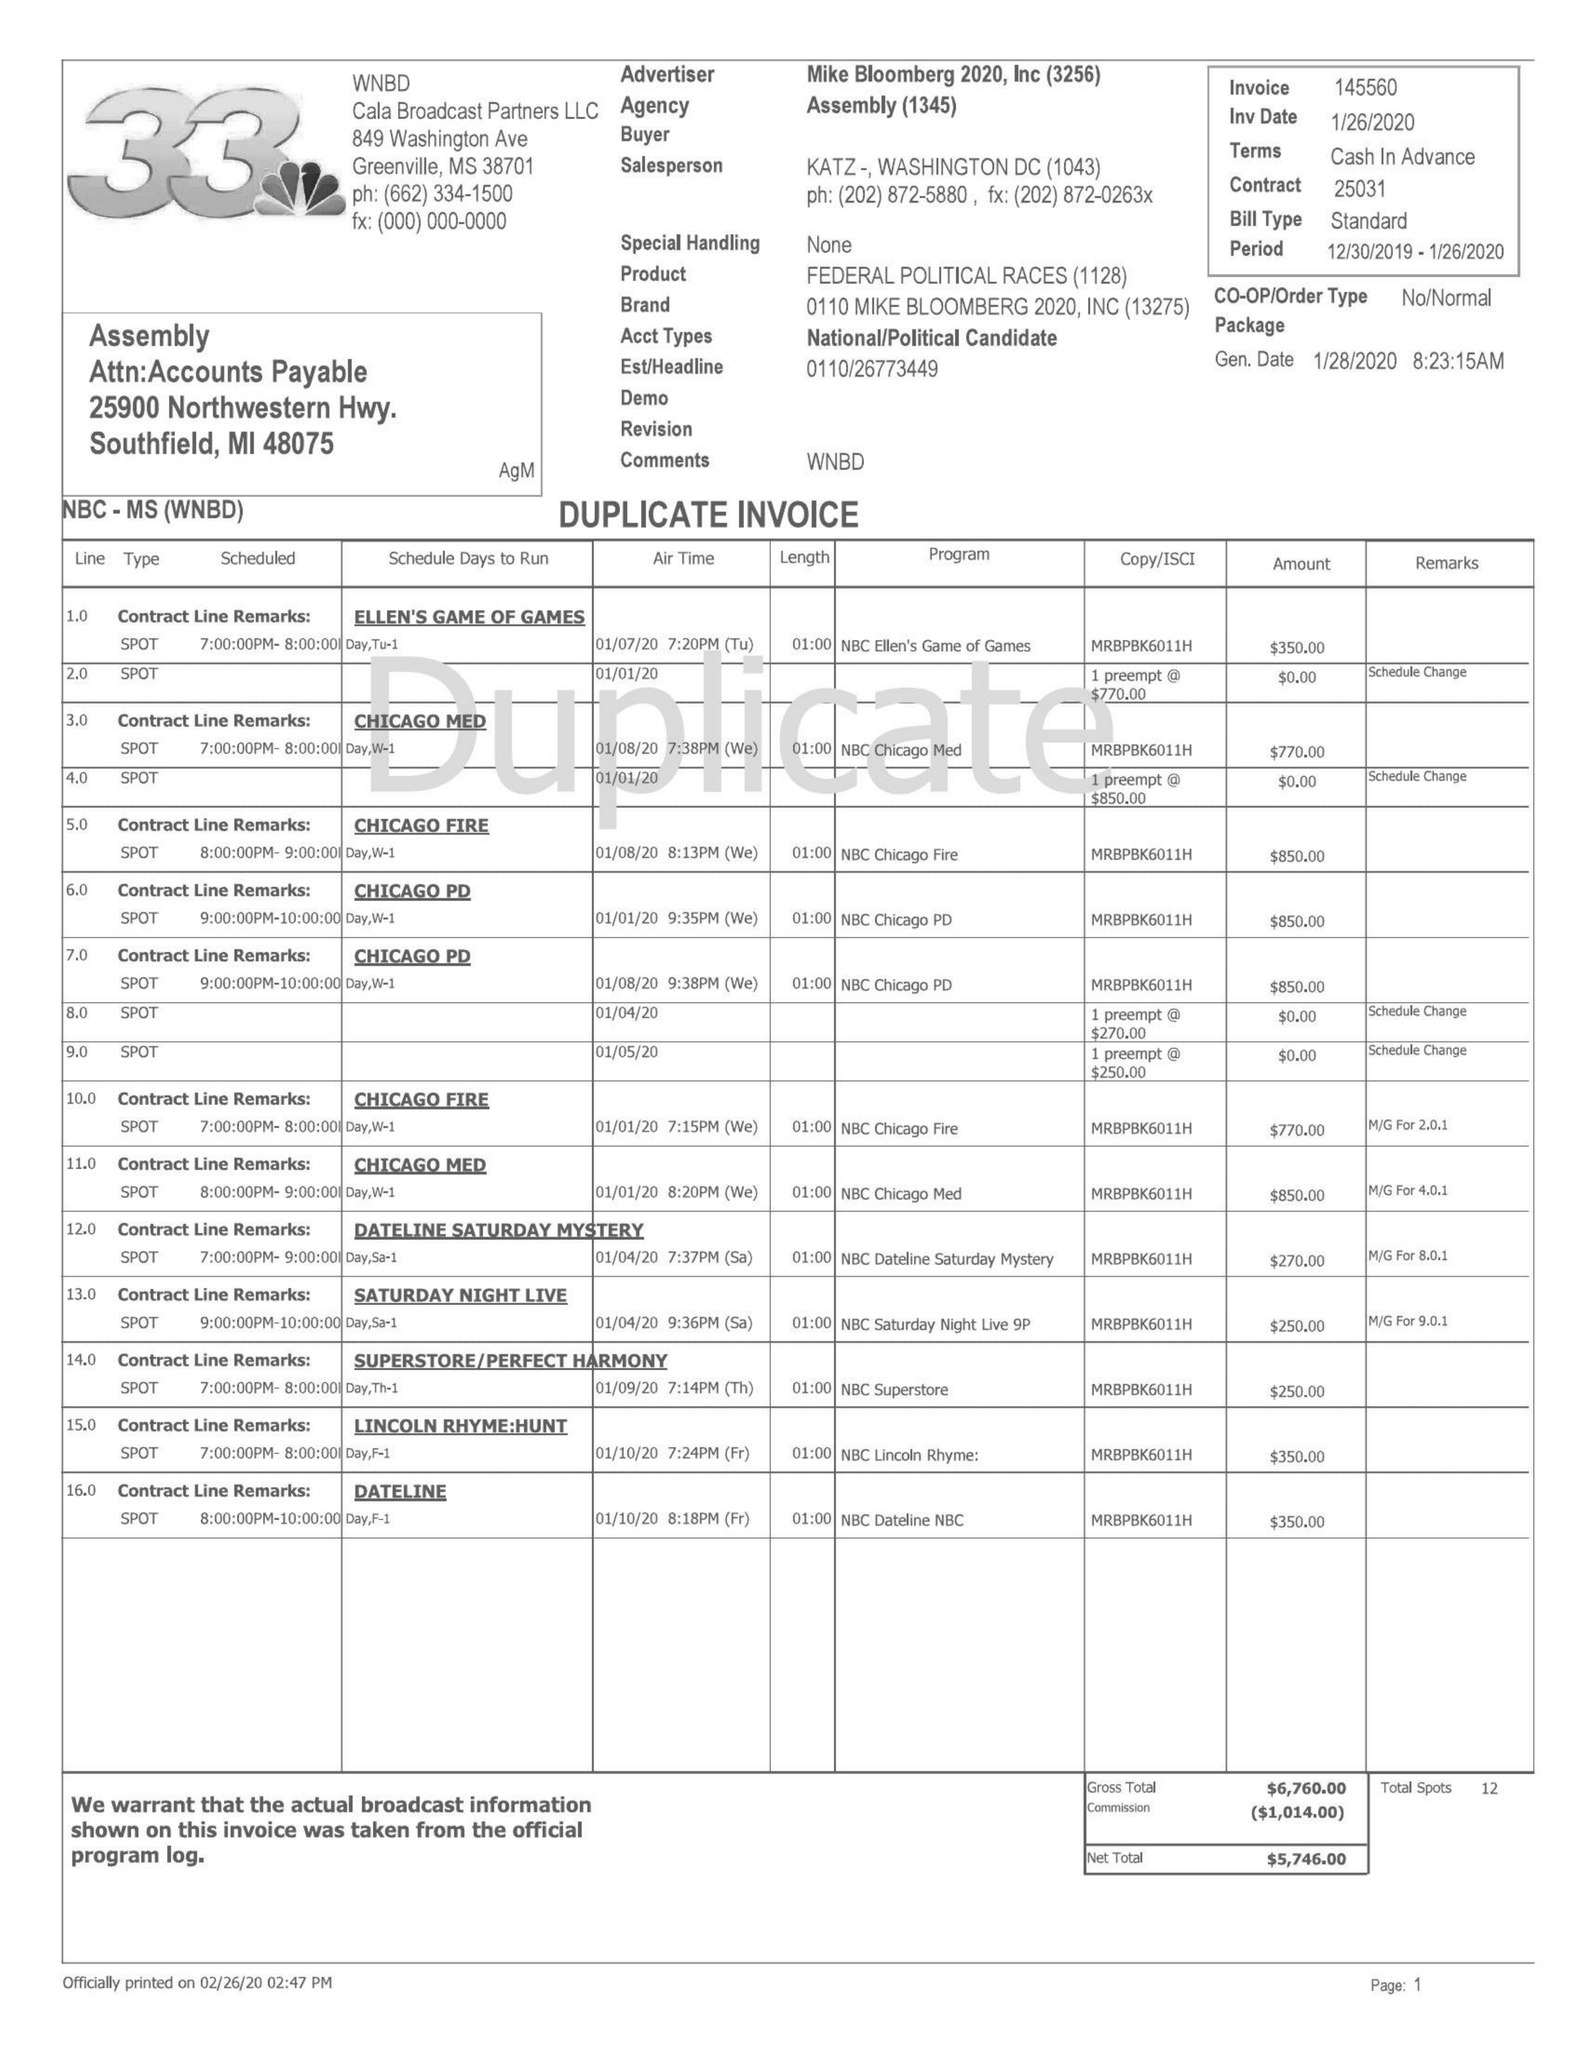What is the value for the gross_amount?
Answer the question using a single word or phrase. 16951.00 